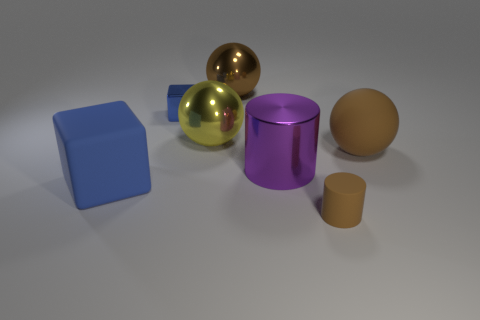Add 2 purple rubber balls. How many objects exist? 9 Subtract all brown spheres. How many spheres are left? 1 Subtract 1 spheres. How many spheres are left? 2 Subtract all brown cylinders. How many cylinders are left? 1 Subtract all blocks. How many objects are left? 5 Subtract all gray cylinders. How many brown spheres are left? 2 Subtract all brown rubber objects. Subtract all cubes. How many objects are left? 3 Add 1 large blocks. How many large blocks are left? 2 Add 3 big green blocks. How many big green blocks exist? 3 Subtract 0 yellow cubes. How many objects are left? 7 